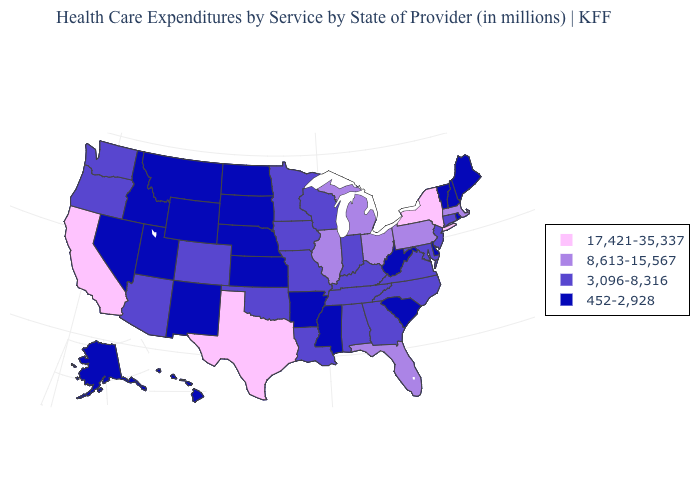Name the states that have a value in the range 452-2,928?
Write a very short answer. Alaska, Arkansas, Delaware, Hawaii, Idaho, Kansas, Maine, Mississippi, Montana, Nebraska, Nevada, New Hampshire, New Mexico, North Dakota, Rhode Island, South Carolina, South Dakota, Utah, Vermont, West Virginia, Wyoming. Does the map have missing data?
Give a very brief answer. No. Which states hav the highest value in the MidWest?
Write a very short answer. Illinois, Michigan, Ohio. Name the states that have a value in the range 8,613-15,567?
Be succinct. Florida, Illinois, Massachusetts, Michigan, Ohio, Pennsylvania. Does Wyoming have the lowest value in the West?
Concise answer only. Yes. Does the map have missing data?
Keep it brief. No. Among the states that border Utah , does Idaho have the lowest value?
Keep it brief. Yes. Does Pennsylvania have the same value as Alaska?
Write a very short answer. No. Which states hav the highest value in the Northeast?
Quick response, please. New York. What is the value of Massachusetts?
Keep it brief. 8,613-15,567. What is the highest value in states that border Kansas?
Keep it brief. 3,096-8,316. Does the first symbol in the legend represent the smallest category?
Give a very brief answer. No. What is the lowest value in the South?
Short answer required. 452-2,928. Which states have the highest value in the USA?
Write a very short answer. California, New York, Texas. Which states have the lowest value in the USA?
Write a very short answer. Alaska, Arkansas, Delaware, Hawaii, Idaho, Kansas, Maine, Mississippi, Montana, Nebraska, Nevada, New Hampshire, New Mexico, North Dakota, Rhode Island, South Carolina, South Dakota, Utah, Vermont, West Virginia, Wyoming. 